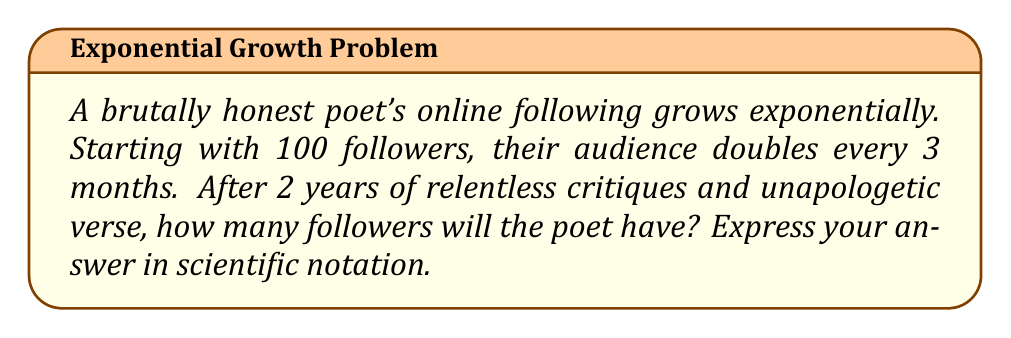Solve this math problem. Let's approach this step-by-step:

1) We're dealing with exponential growth, so we'll use the formula:
   $A = A_0 \cdot b^t$
   Where:
   $A$ is the final amount
   $A_0$ is the initial amount
   $b$ is the growth factor
   $t$ is the number of time periods

2) Given:
   $A_0 = 100$ (initial followers)
   $b = 2$ (doubles every period)
   $t = 8$ (2 years = 8 three-month periods)

3) Plugging these into our formula:
   $A = 100 \cdot 2^8$

4) Let's calculate:
   $A = 100 \cdot 256 = 25,600$

5) To express this in scientific notation:
   $25,600 = 2.56 \times 10^4$

Thus, after 2 years, the poet will have $2.56 \times 10^4$ followers.
Answer: $2.56 \times 10^4$ 